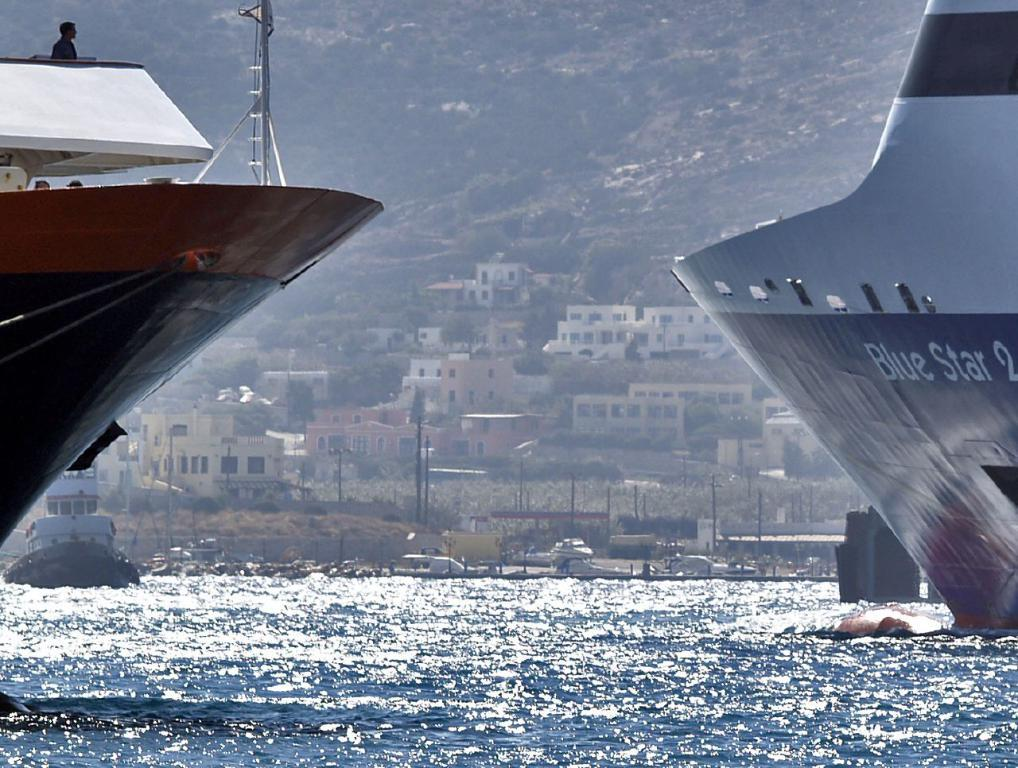<image>
Provide a brief description of the given image. two ships one on the right called the Blue Star 